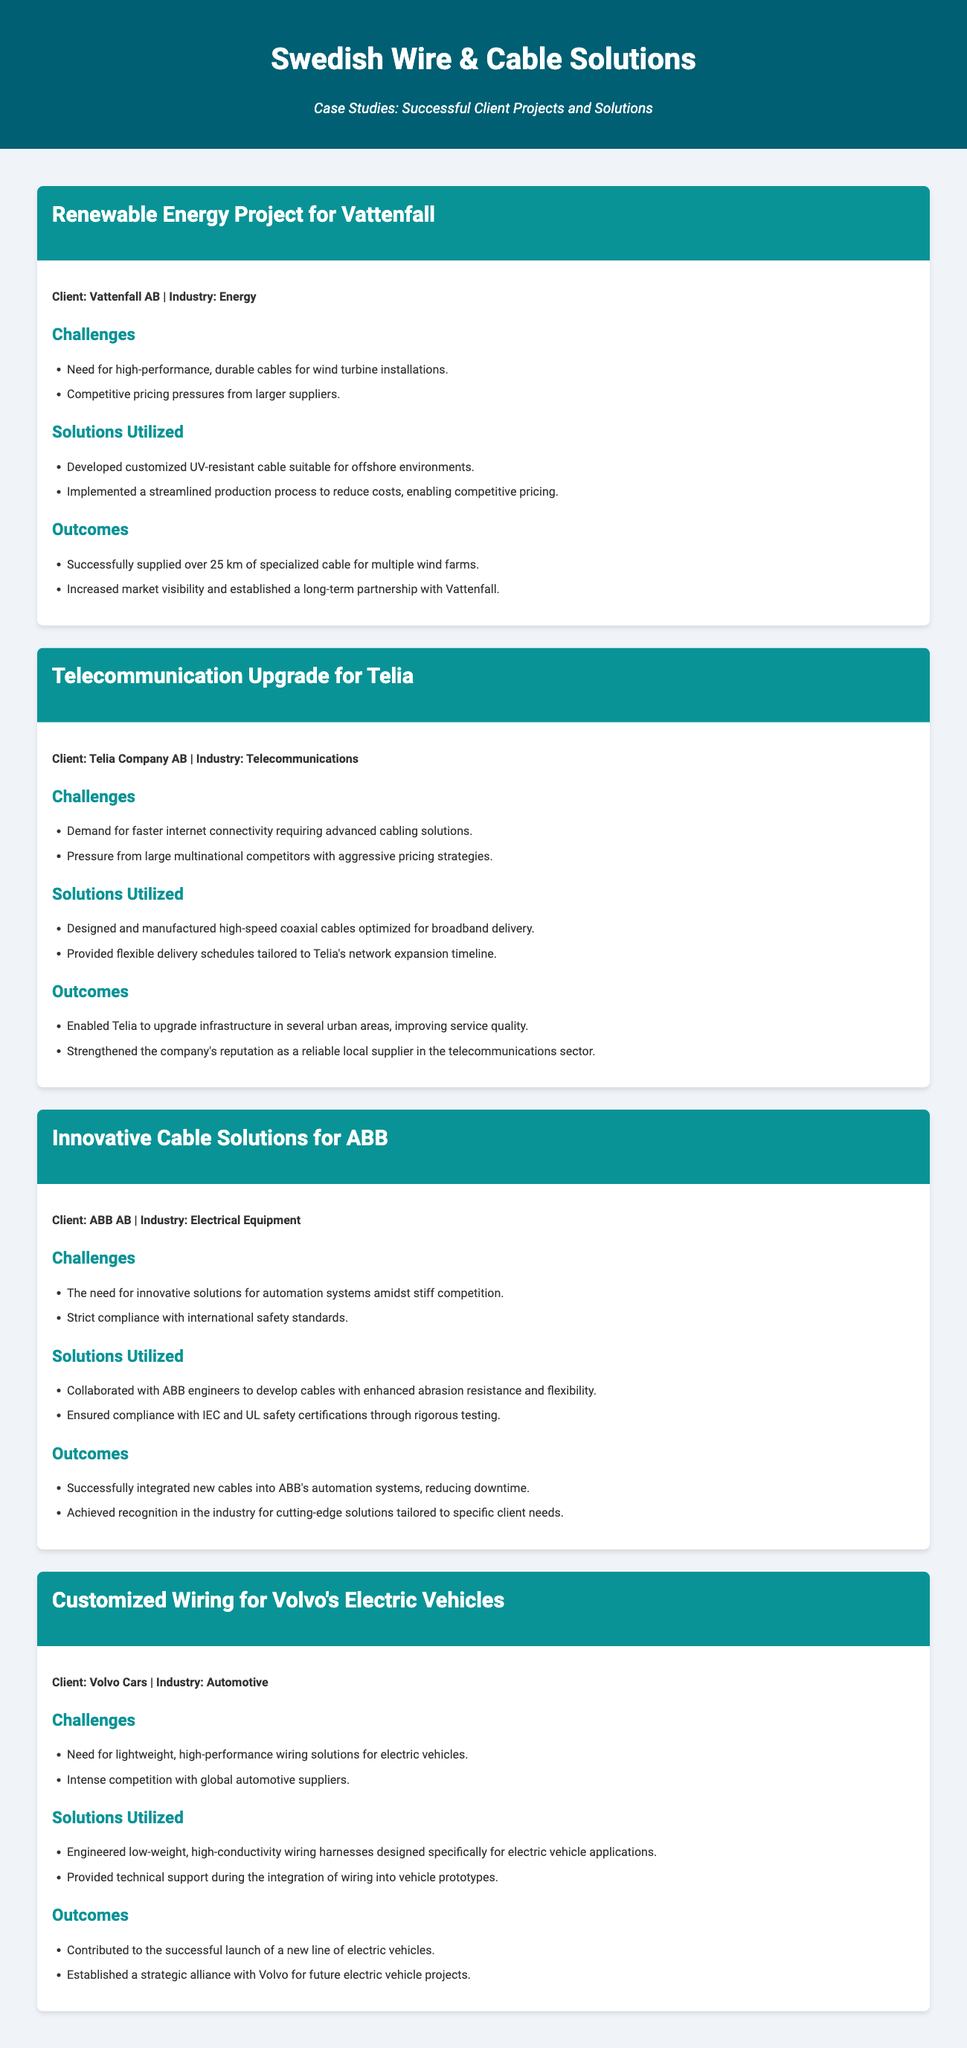What is the name of the first client featured? The first client mentioned in the document is Vattenfall AB, featured in the Renewable Energy Project case study.
Answer: Vattenfall AB What industry does Telia operate in? The document specifies that Telia Company AB operates in the Telecommunications industry.
Answer: Telecommunications How many kilometers of cable were supplied to Vattenfall? The document states that over 25 km of specialized cable were supplied for multiple wind farms.
Answer: 25 km What innovative feature was provided for Volvo's electric vehicles? The document mentions that low-weight, high-conductivity wiring harnesses were engineered specifically for electric vehicle applications.
Answer: Low-weight, high-conductivity wiring harnesses Which safety standards were complied with in the project for ABB? The document notes that compliance with IEC and UL safety certifications was ensured through rigorous testing.
Answer: IEC and UL What was the primary challenge faced by Volvo in the case study? The document states that a primary challenge was the need for lightweight, high-performance wiring solutions for electric vehicles.
Answer: Lightweight, high-performance wiring solutions What was a solution utilized in the telecommunications upgrade for Telia? The document mentions that high-speed coaxial cables optimized for broadband delivery were designed and manufactured as a solution.
Answer: High-speed coaxial cables What was the outcome of the renewable energy project for Vattenfall? The document highlights that a long-term partnership with Vattenfall was established as an outcome of the project.
Answer: Long-term partnership with Vattenfall 